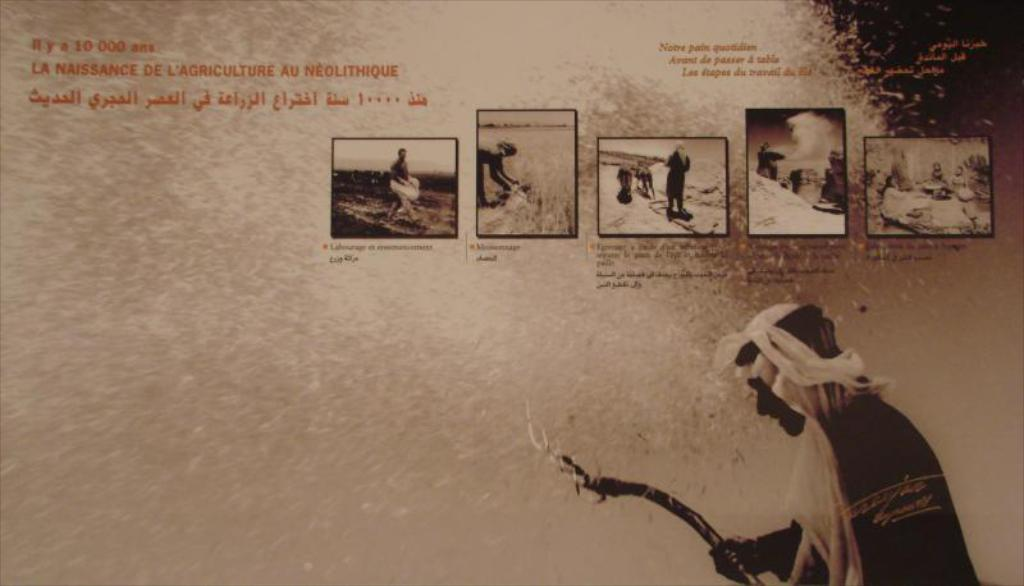What is the person in the image doing? The person is standing in the image and holding a stick. What can be seen on the poster in the image? There are images, words, and numbers on the poster. How many friends are sitting on the bed in the image? There is no bed or friends present in the image. What type of finger can be seen pointing at the numbers on the poster? There are no fingers visible in the image, and the numbers on the poster are not being pointed at. 